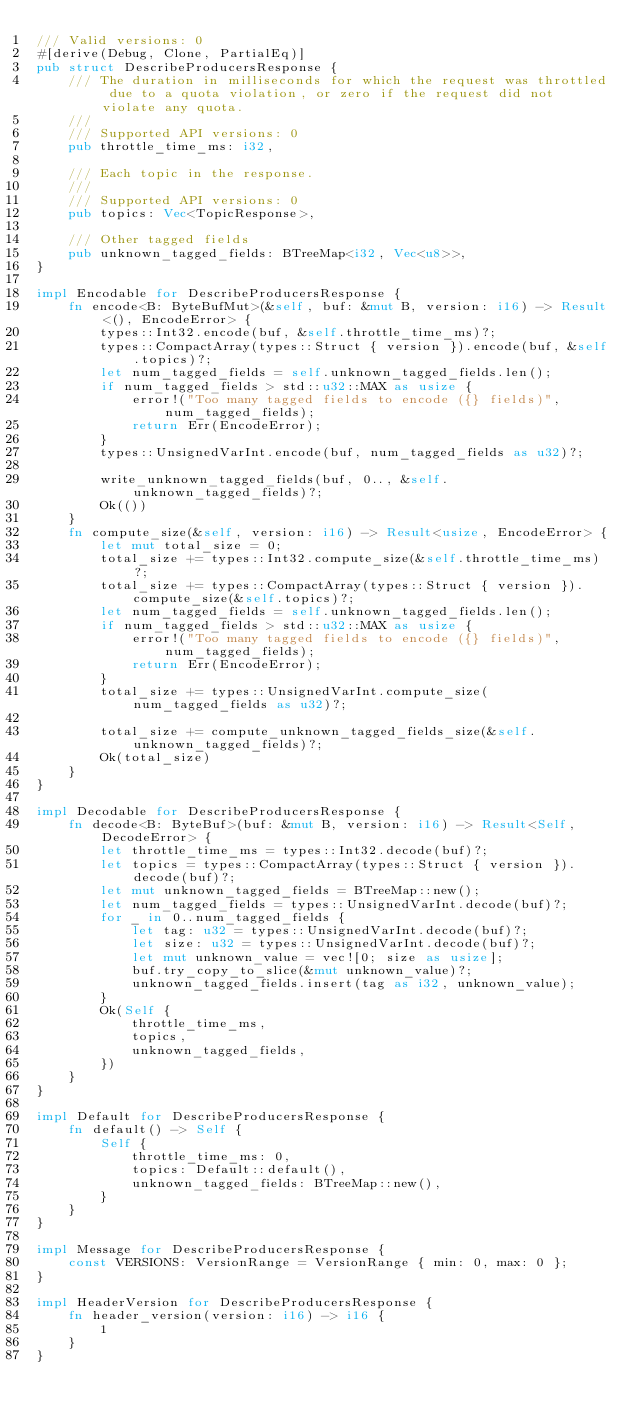Convert code to text. <code><loc_0><loc_0><loc_500><loc_500><_Rust_>/// Valid versions: 0
#[derive(Debug, Clone, PartialEq)]
pub struct DescribeProducersResponse {
    /// The duration in milliseconds for which the request was throttled due to a quota violation, or zero if the request did not violate any quota.
    /// 
    /// Supported API versions: 0
    pub throttle_time_ms: i32,

    /// Each topic in the response.
    /// 
    /// Supported API versions: 0
    pub topics: Vec<TopicResponse>,

    /// Other tagged fields
    pub unknown_tagged_fields: BTreeMap<i32, Vec<u8>>,
}

impl Encodable for DescribeProducersResponse {
    fn encode<B: ByteBufMut>(&self, buf: &mut B, version: i16) -> Result<(), EncodeError> {
        types::Int32.encode(buf, &self.throttle_time_ms)?;
        types::CompactArray(types::Struct { version }).encode(buf, &self.topics)?;
        let num_tagged_fields = self.unknown_tagged_fields.len();
        if num_tagged_fields > std::u32::MAX as usize {
            error!("Too many tagged fields to encode ({} fields)", num_tagged_fields);
            return Err(EncodeError);
        }
        types::UnsignedVarInt.encode(buf, num_tagged_fields as u32)?;

        write_unknown_tagged_fields(buf, 0.., &self.unknown_tagged_fields)?;
        Ok(())
    }
    fn compute_size(&self, version: i16) -> Result<usize, EncodeError> {
        let mut total_size = 0;
        total_size += types::Int32.compute_size(&self.throttle_time_ms)?;
        total_size += types::CompactArray(types::Struct { version }).compute_size(&self.topics)?;
        let num_tagged_fields = self.unknown_tagged_fields.len();
        if num_tagged_fields > std::u32::MAX as usize {
            error!("Too many tagged fields to encode ({} fields)", num_tagged_fields);
            return Err(EncodeError);
        }
        total_size += types::UnsignedVarInt.compute_size(num_tagged_fields as u32)?;

        total_size += compute_unknown_tagged_fields_size(&self.unknown_tagged_fields)?;
        Ok(total_size)
    }
}

impl Decodable for DescribeProducersResponse {
    fn decode<B: ByteBuf>(buf: &mut B, version: i16) -> Result<Self, DecodeError> {
        let throttle_time_ms = types::Int32.decode(buf)?;
        let topics = types::CompactArray(types::Struct { version }).decode(buf)?;
        let mut unknown_tagged_fields = BTreeMap::new();
        let num_tagged_fields = types::UnsignedVarInt.decode(buf)?;
        for _ in 0..num_tagged_fields {
            let tag: u32 = types::UnsignedVarInt.decode(buf)?;
            let size: u32 = types::UnsignedVarInt.decode(buf)?;
            let mut unknown_value = vec![0; size as usize];
            buf.try_copy_to_slice(&mut unknown_value)?;
            unknown_tagged_fields.insert(tag as i32, unknown_value);
        }
        Ok(Self {
            throttle_time_ms,
            topics,
            unknown_tagged_fields,
        })
    }
}

impl Default for DescribeProducersResponse {
    fn default() -> Self {
        Self {
            throttle_time_ms: 0,
            topics: Default::default(),
            unknown_tagged_fields: BTreeMap::new(),
        }
    }
}

impl Message for DescribeProducersResponse {
    const VERSIONS: VersionRange = VersionRange { min: 0, max: 0 };
}

impl HeaderVersion for DescribeProducersResponse {
    fn header_version(version: i16) -> i16 {
        1
    }
}

</code> 